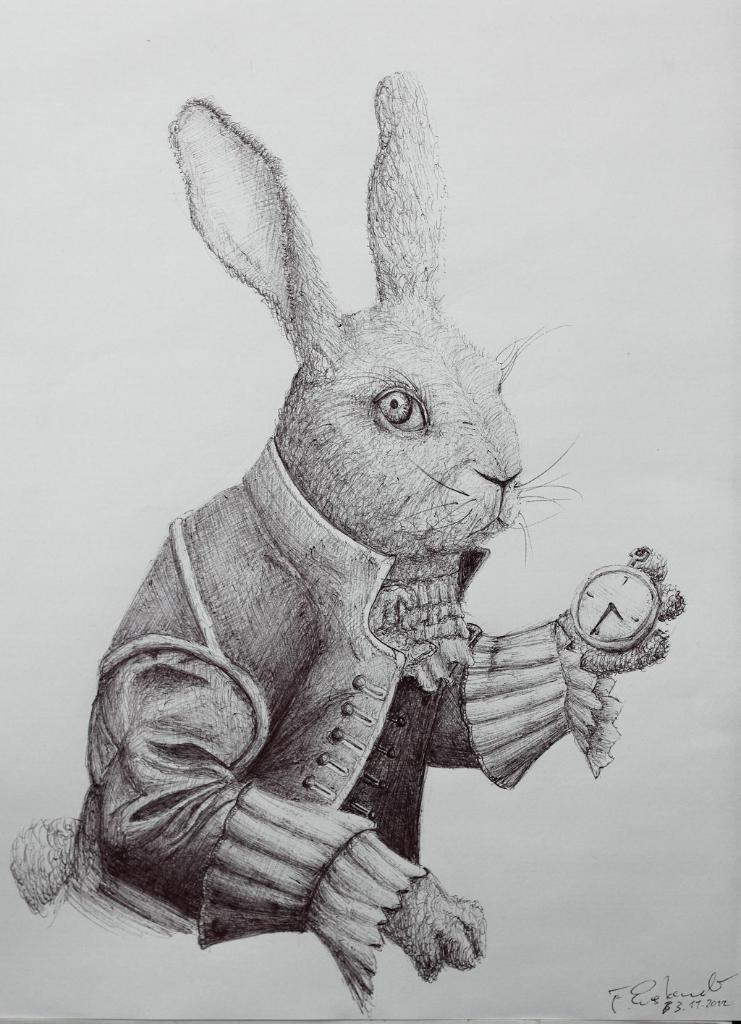What is depicted on the paper in the image? There is an art in the image, featuring a rabbit. What tool was used to create the art? The art is done with a pencil. What is the rabbit holding in its hand? The rabbit is holding a stopwatch in its hand. How many yams are present in the image? There are no yams present in the image. Can you describe the color of the lizards in the image? There are no lizards present in the image. 